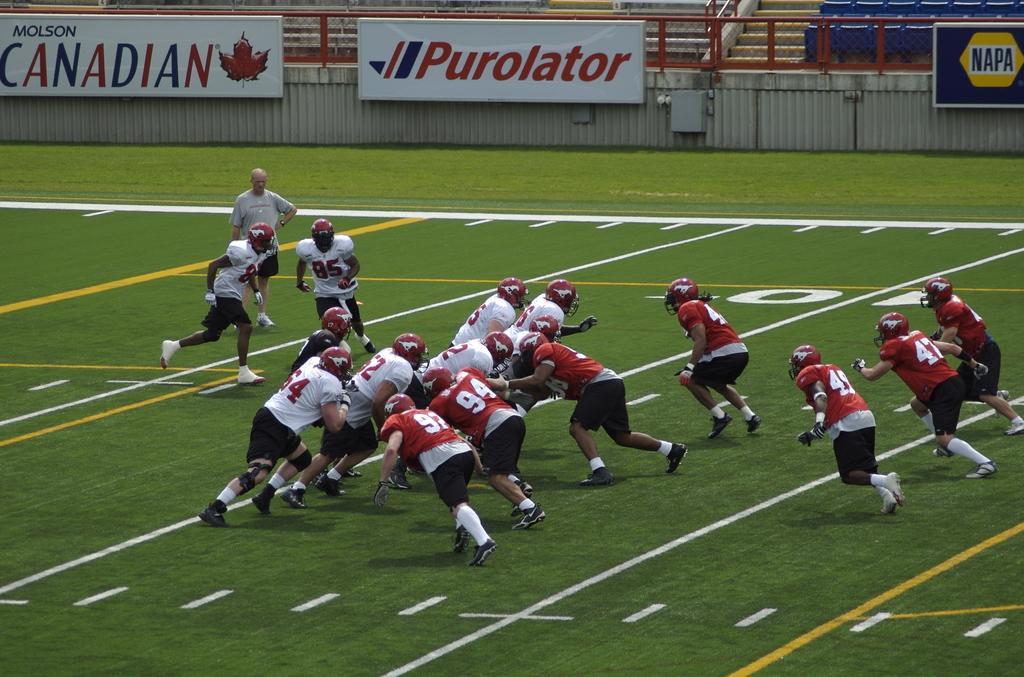How would you summarize this image in a sentence or two? In the picture I can see people wearing red T-shirts are on the right side of the image and the people wearing white T-shirts are on the left side of the image and they are playing on the green grass ground. In the background, we can see boards the wall and the chairs in the stadium. 